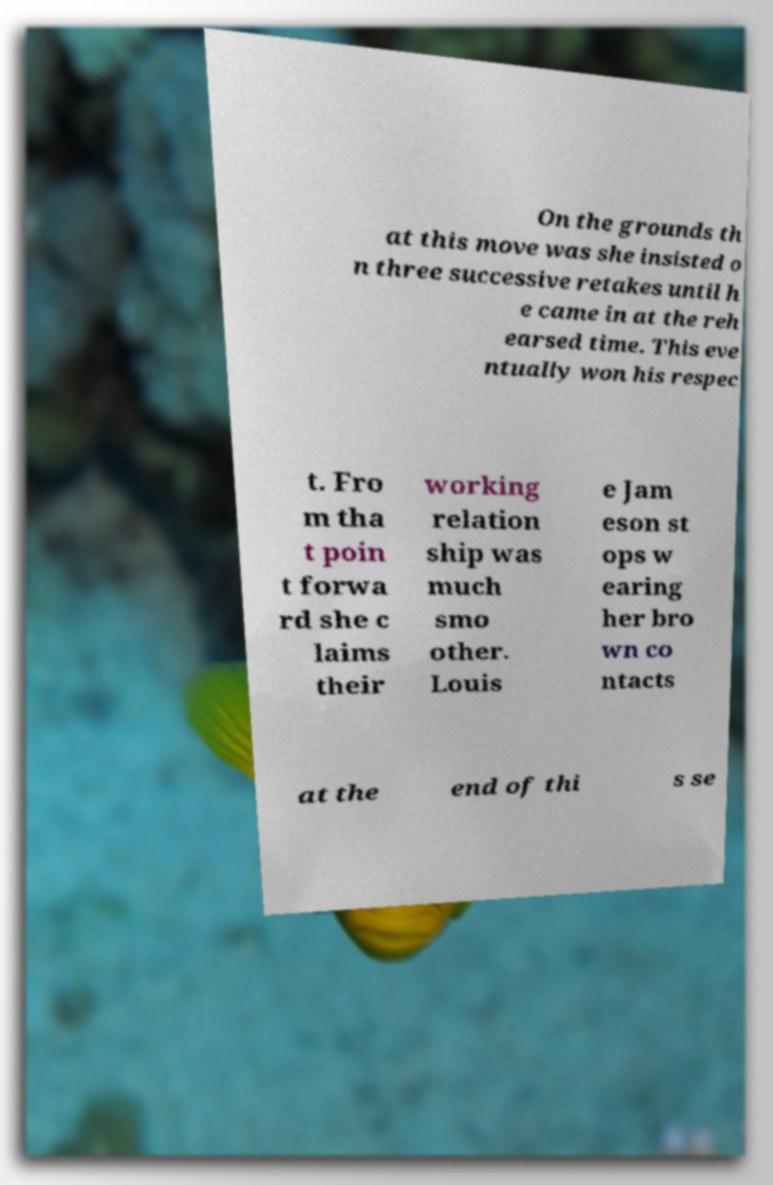What messages or text are displayed in this image? I need them in a readable, typed format. On the grounds th at this move was she insisted o n three successive retakes until h e came in at the reh earsed time. This eve ntually won his respec t. Fro m tha t poin t forwa rd she c laims their working relation ship was much smo other. Louis e Jam eson st ops w earing her bro wn co ntacts at the end of thi s se 